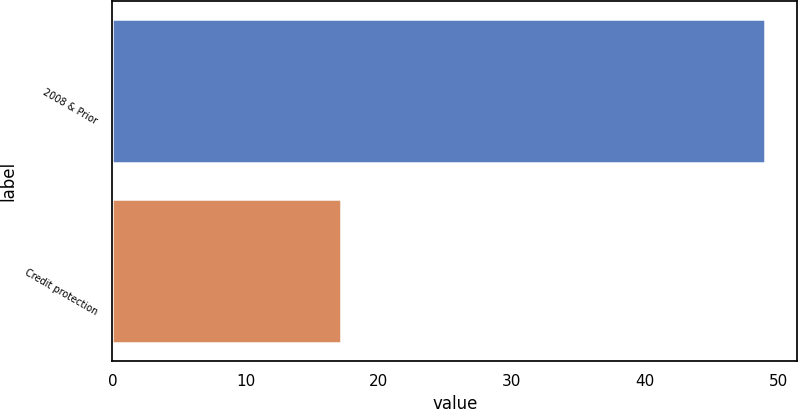Convert chart. <chart><loc_0><loc_0><loc_500><loc_500><bar_chart><fcel>2008 & Prior<fcel>Credit protection<nl><fcel>49<fcel>17.2<nl></chart> 